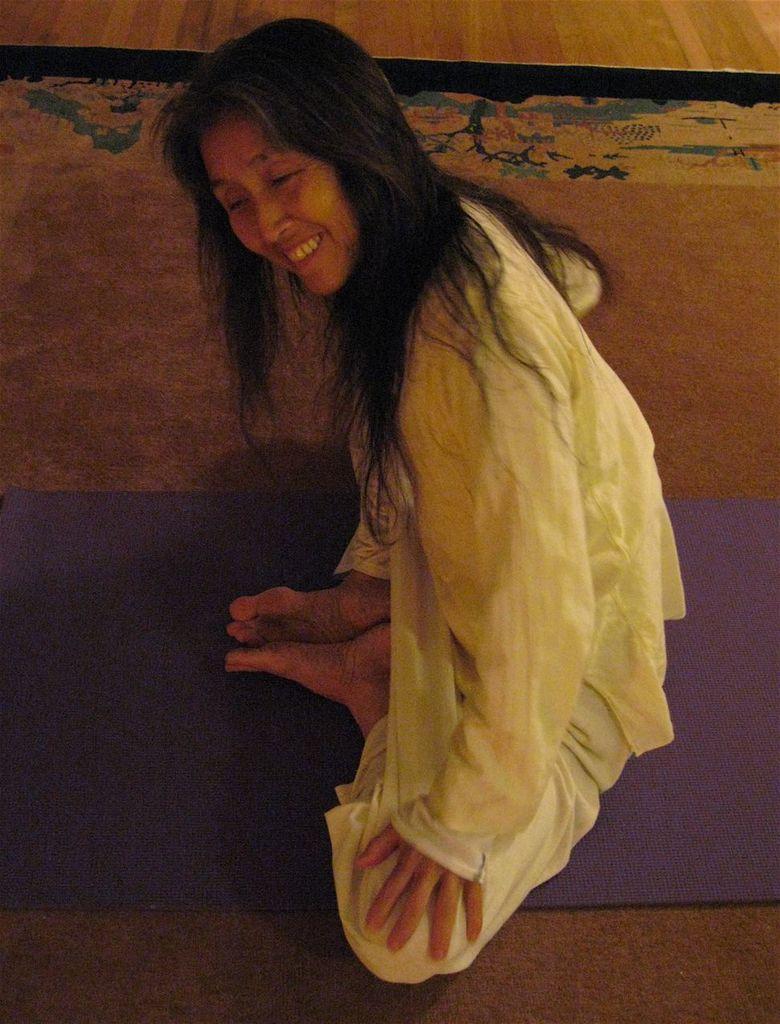Can you describe this image briefly? The woman in white dress is sitting on the purple color sheet. She is performing yoga. She is smiling. Beside her, we see a brown color carpet. This picture might be clicked inside the room. 